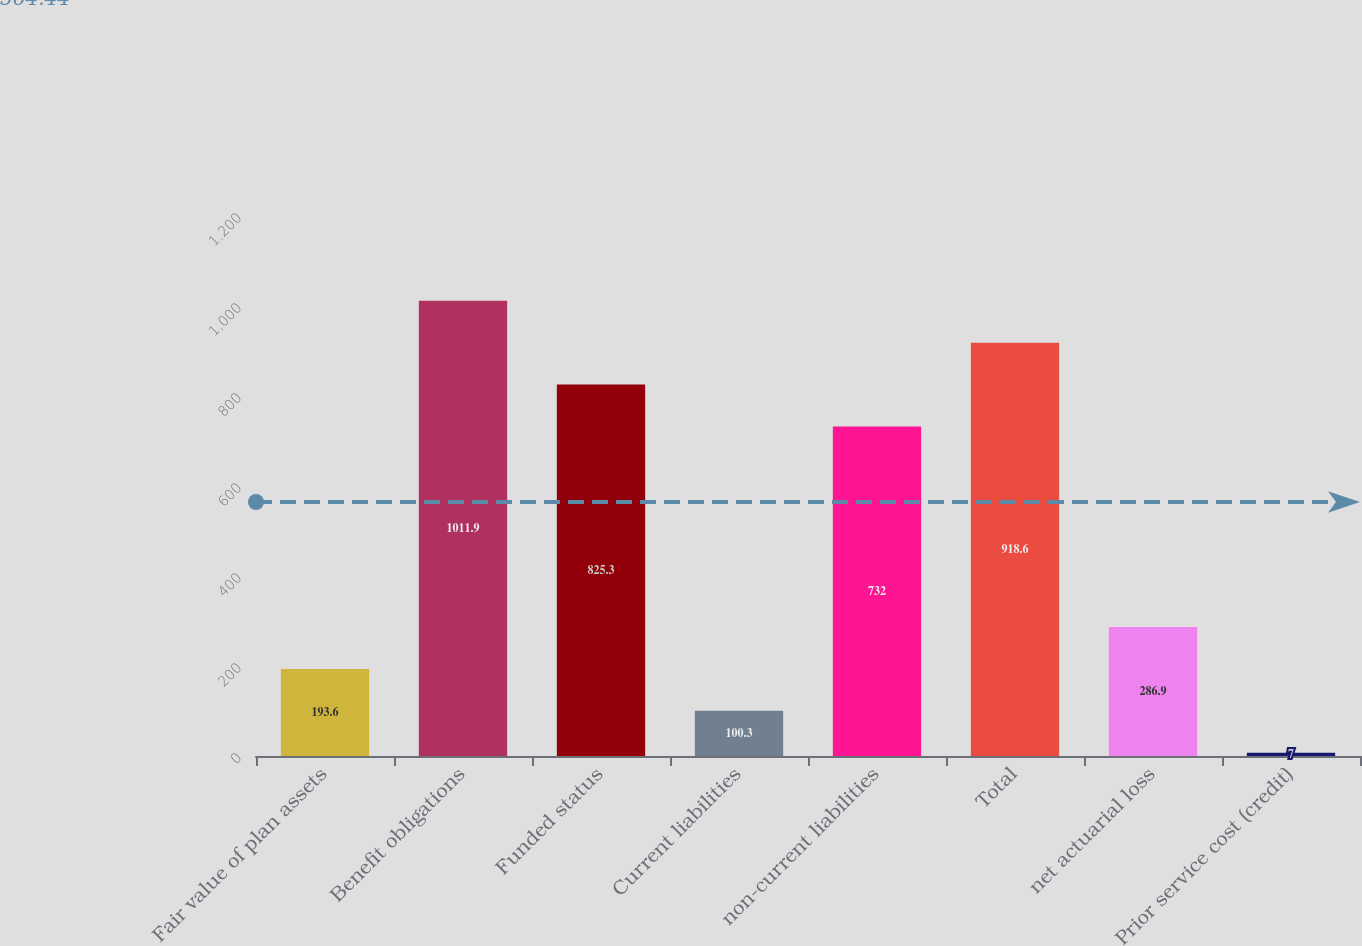<chart> <loc_0><loc_0><loc_500><loc_500><bar_chart><fcel>Fair value of plan assets<fcel>Benefit obligations<fcel>Funded status<fcel>Current liabilities<fcel>non-current liabilities<fcel>Total<fcel>net actuarial loss<fcel>Prior service cost (credit)<nl><fcel>193.6<fcel>1011.9<fcel>825.3<fcel>100.3<fcel>732<fcel>918.6<fcel>286.9<fcel>7<nl></chart> 